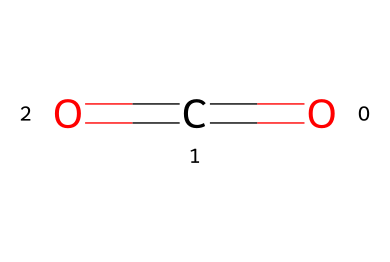What is the name of this chemical? The SMILES representation provided (O=C=O) corresponds to carbon dioxide, which is commonly known as CO2.
Answer: carbon dioxide How many oxygen atoms are present in this structure? The SMILES notation shows two oxygen atoms attached to a central carbon atom, indicating the presence of two oxygen atoms.
Answer: two What type of bonds are present in carbon dioxide? The structure shows double bonds between the carbon atom and each of the oxygen atoms, indicating that the chemical has two double bonds.
Answer: double bonds Is this refrigerant a greenhouse gas? Carbon dioxide is known to be a greenhouse gas due to its ability to trap heat in the atmosphere, contributing to global warming.
Answer: yes What is a primary application of carbon dioxide in refrigeration? Carbon dioxide is primarily used as a sustainable refrigerant in heat pumps and supermarket refrigeration systems due to its low environmental impact.
Answer: heat pumps and supermarket refrigeration systems How many total atoms are in carbon dioxide? The structure shows one carbon atom and two oxygen atoms, resulting in a total of three atoms in carbon dioxide.
Answer: three What makes carbon dioxide suitable for use as a refrigerant? Carbon dioxide has low environmental impact, good efficiency at low temperatures, and low toxicity, which makes it suitable for use as a refrigerant.
Answer: low environmental impact and efficiency at low temperatures 